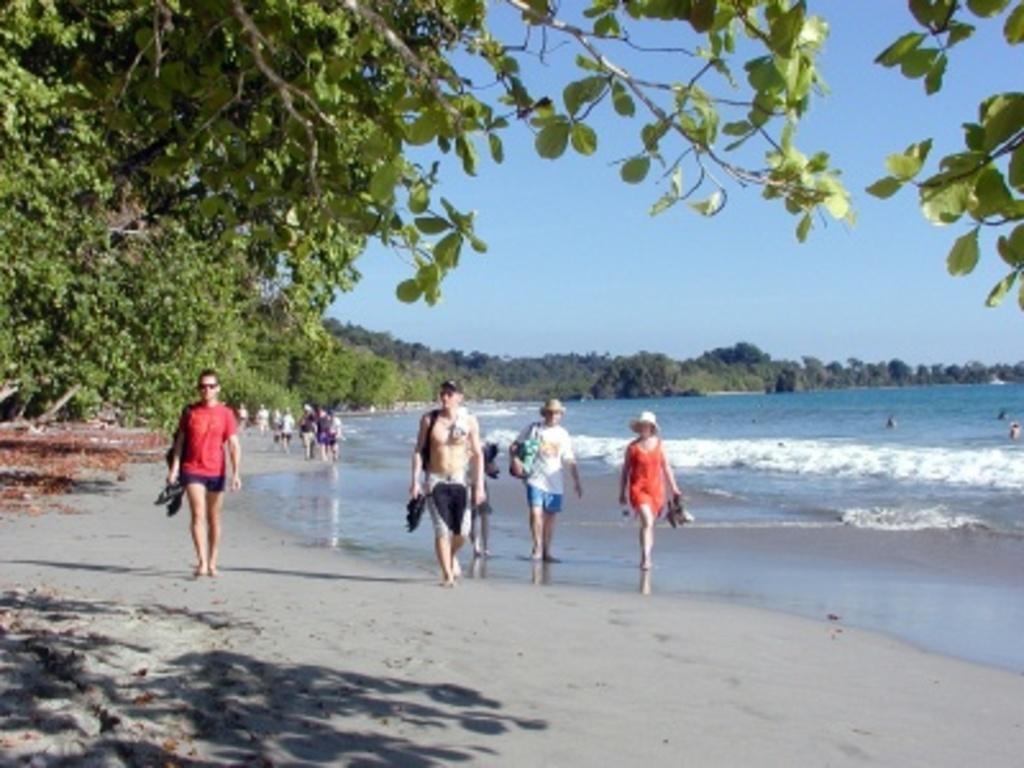Could you give a brief overview of what you see in this image? As we can see in the image there are few people here and there walking, trees and water. On the top there is sky. 